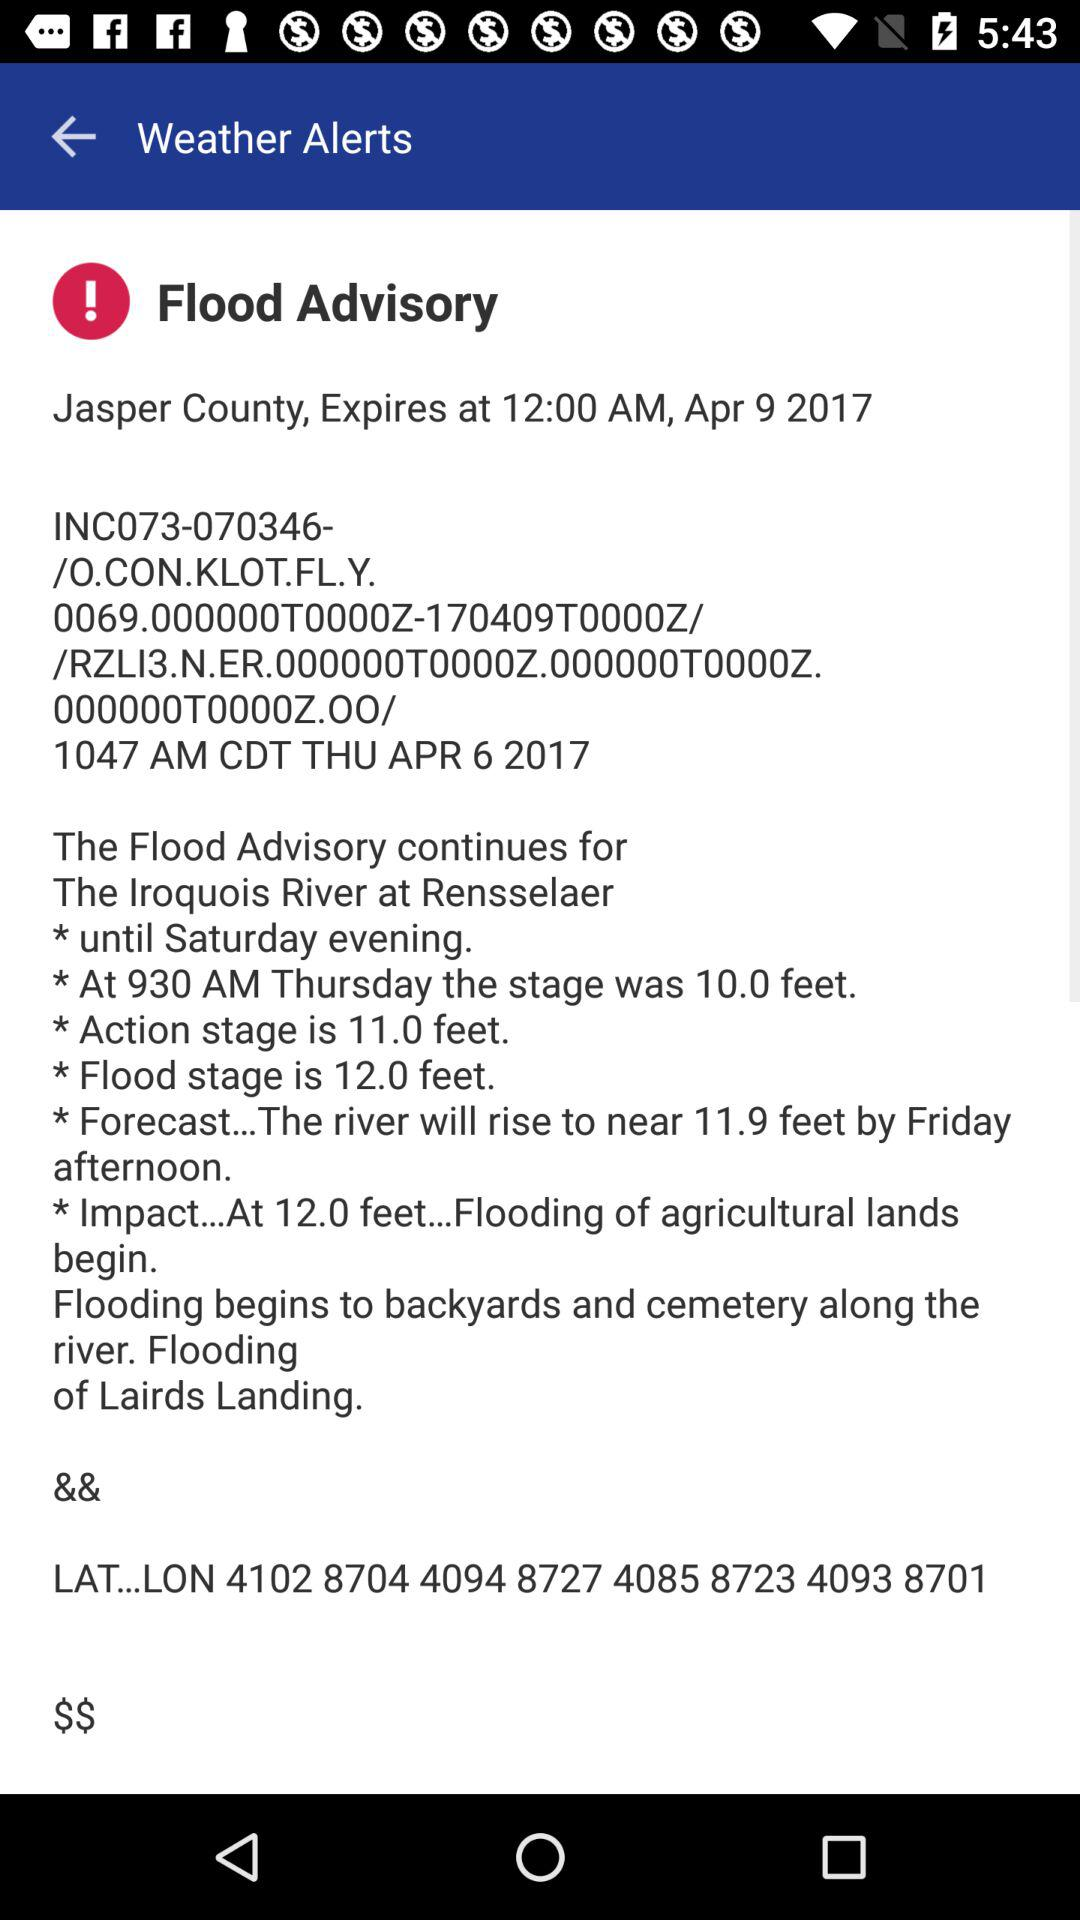What's the expiration date? The expiration date is April 9, 2017. 